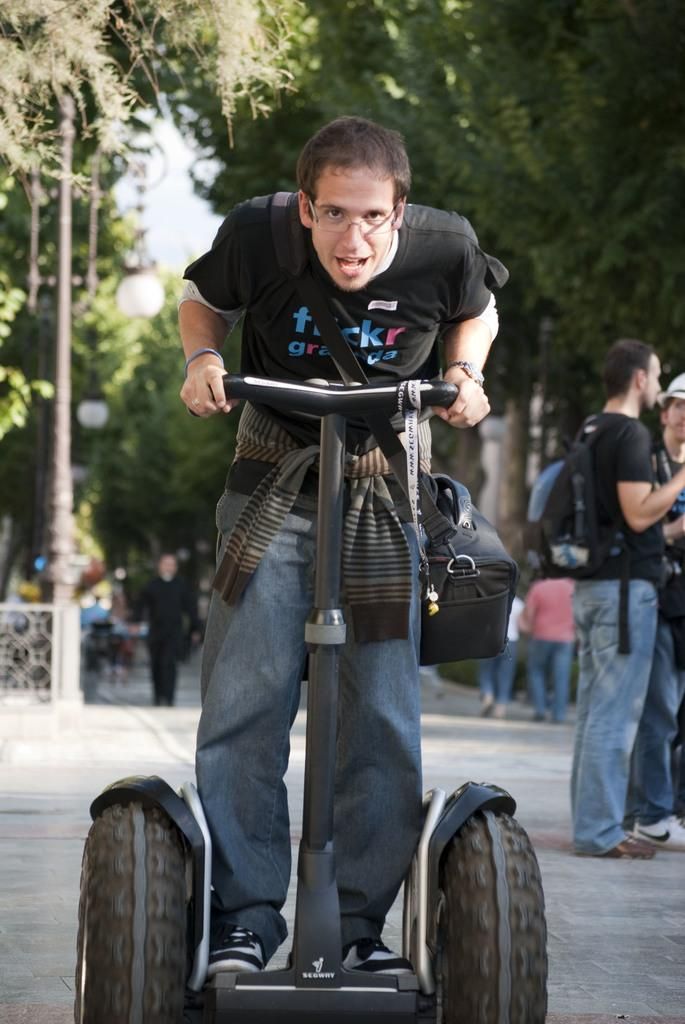What can be seen in the image involving transportation? A segway is visible in the image. What are the people in the image doing? The people standing in the image are likely observing or interacting with the segway. What can be seen in the background of the image? There are street lights and trees in the background of the image. What is visible at the top of the image? The sky is visible at the top of the image. What type of alarm is ringing in the image? There is no alarm present in the image. Can you see any ducks in the image? There are no ducks present in the image. 